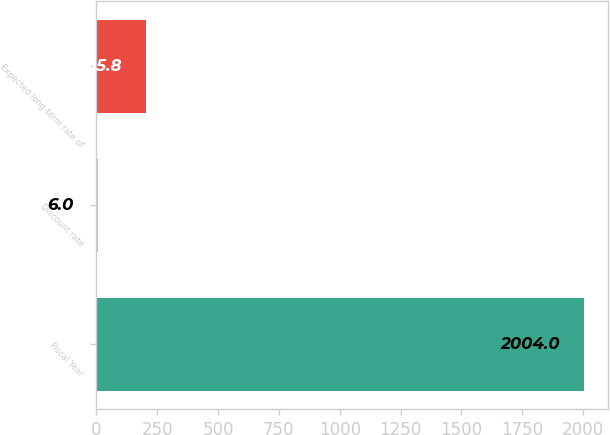Convert chart to OTSL. <chart><loc_0><loc_0><loc_500><loc_500><bar_chart><fcel>Fiscal Year<fcel>Discount rate<fcel>Expected long-term rate of<nl><fcel>2004<fcel>6<fcel>205.8<nl></chart> 